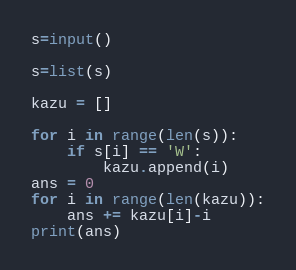<code> <loc_0><loc_0><loc_500><loc_500><_Python_>s=input()

s=list(s)

kazu = []

for i in range(len(s)):
    if s[i] == 'W':
        kazu.append(i)
ans = 0
for i in range(len(kazu)):
    ans += kazu[i]-i
print(ans)</code> 